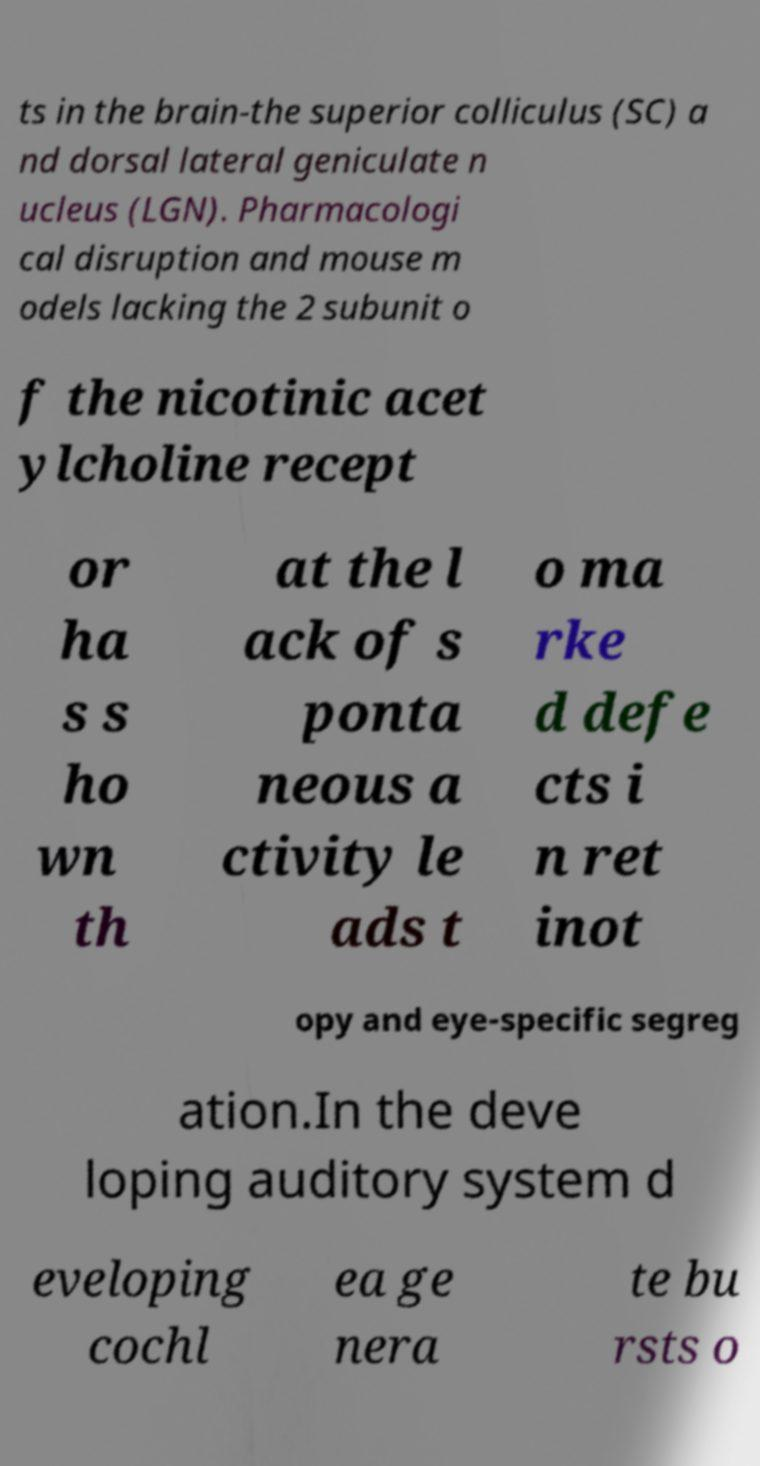Could you extract and type out the text from this image? ts in the brain-the superior colliculus (SC) a nd dorsal lateral geniculate n ucleus (LGN). Pharmacologi cal disruption and mouse m odels lacking the 2 subunit o f the nicotinic acet ylcholine recept or ha s s ho wn th at the l ack of s ponta neous a ctivity le ads t o ma rke d defe cts i n ret inot opy and eye-specific segreg ation.In the deve loping auditory system d eveloping cochl ea ge nera te bu rsts o 